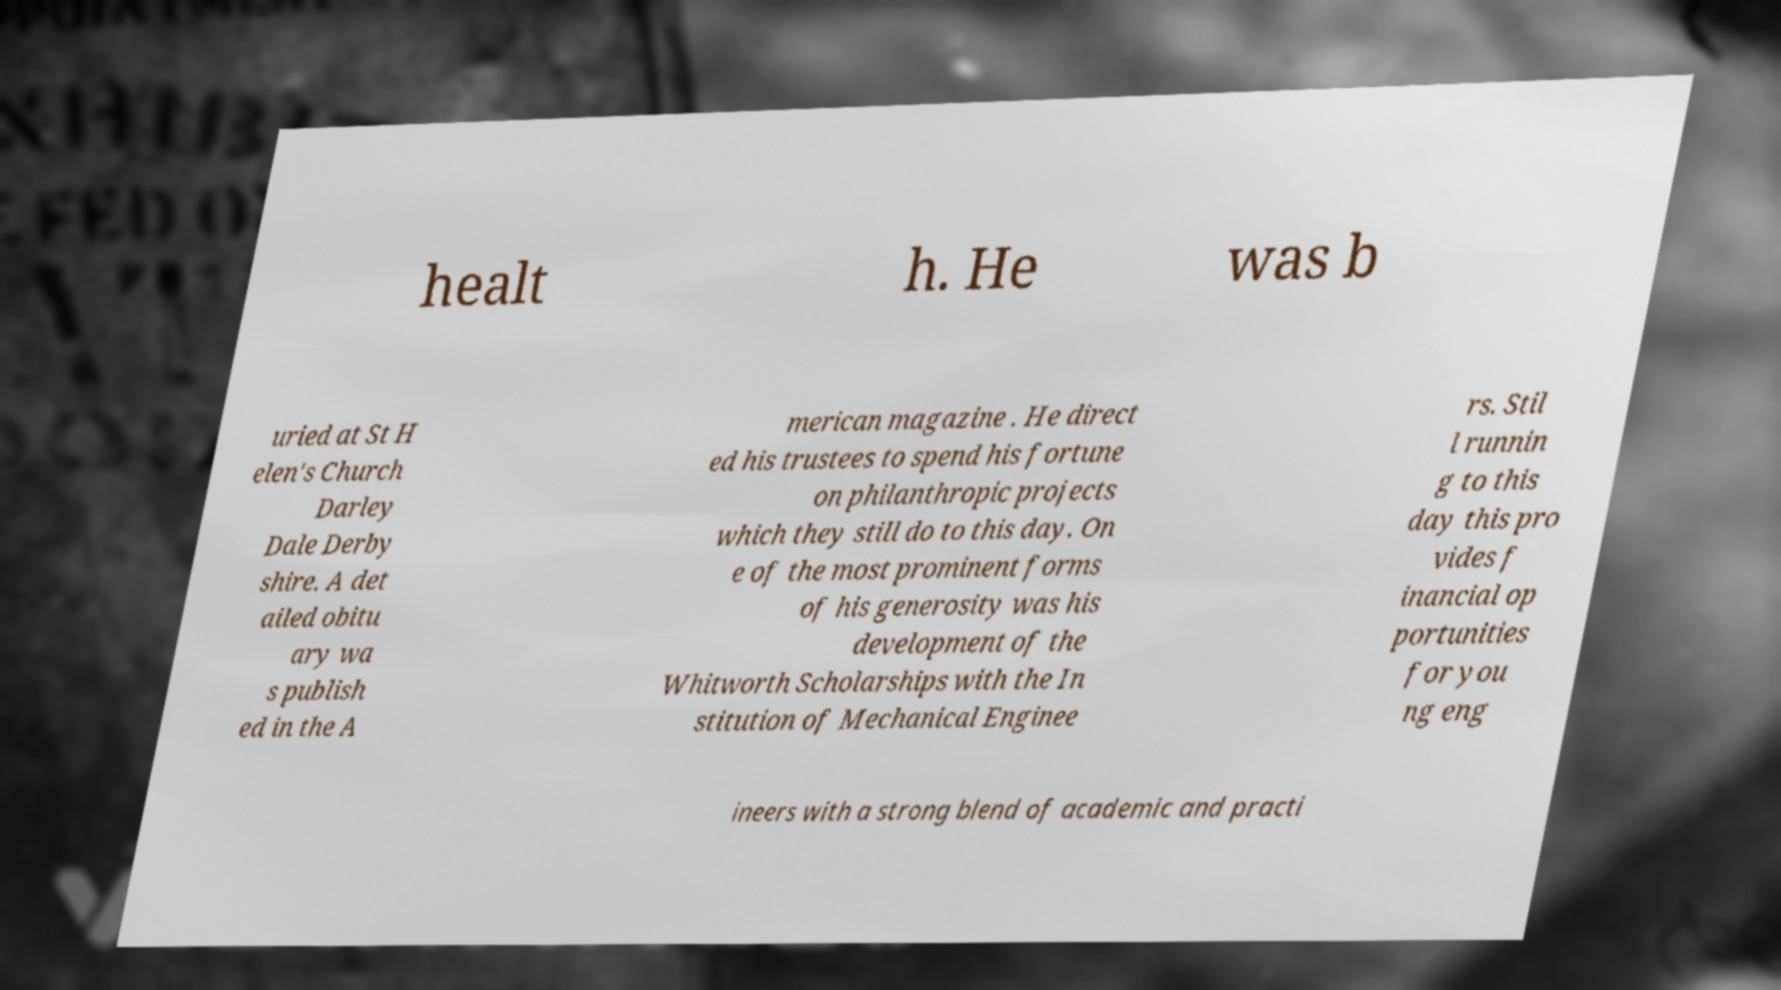Could you assist in decoding the text presented in this image and type it out clearly? healt h. He was b uried at St H elen's Church Darley Dale Derby shire. A det ailed obitu ary wa s publish ed in the A merican magazine . He direct ed his trustees to spend his fortune on philanthropic projects which they still do to this day. On e of the most prominent forms of his generosity was his development of the Whitworth Scholarships with the In stitution of Mechanical Enginee rs. Stil l runnin g to this day this pro vides f inancial op portunities for you ng eng ineers with a strong blend of academic and practi 